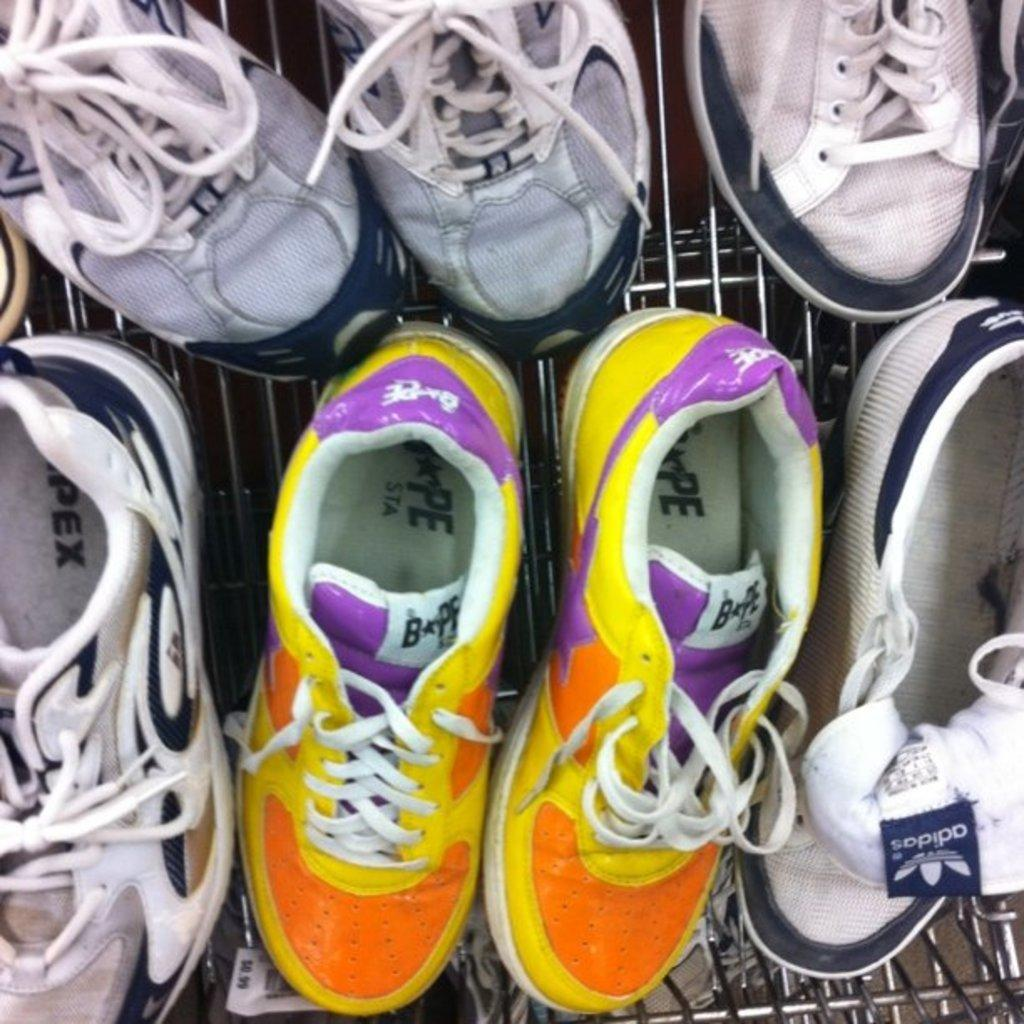What is the main object in the image? There is a shoe rack in the image. What is on the shoe rack? The shoe rack has shoes on it. Can you describe one of the pairs of shoes on the shoe rack? One pair of shoes is yellow, orange, and violet in color. What type of canvas is used to create the mint-flavored shoes in the image? There are no mint-flavored shoes or canvas mentioned in the image; it only features a shoe rack with shoes on it. 